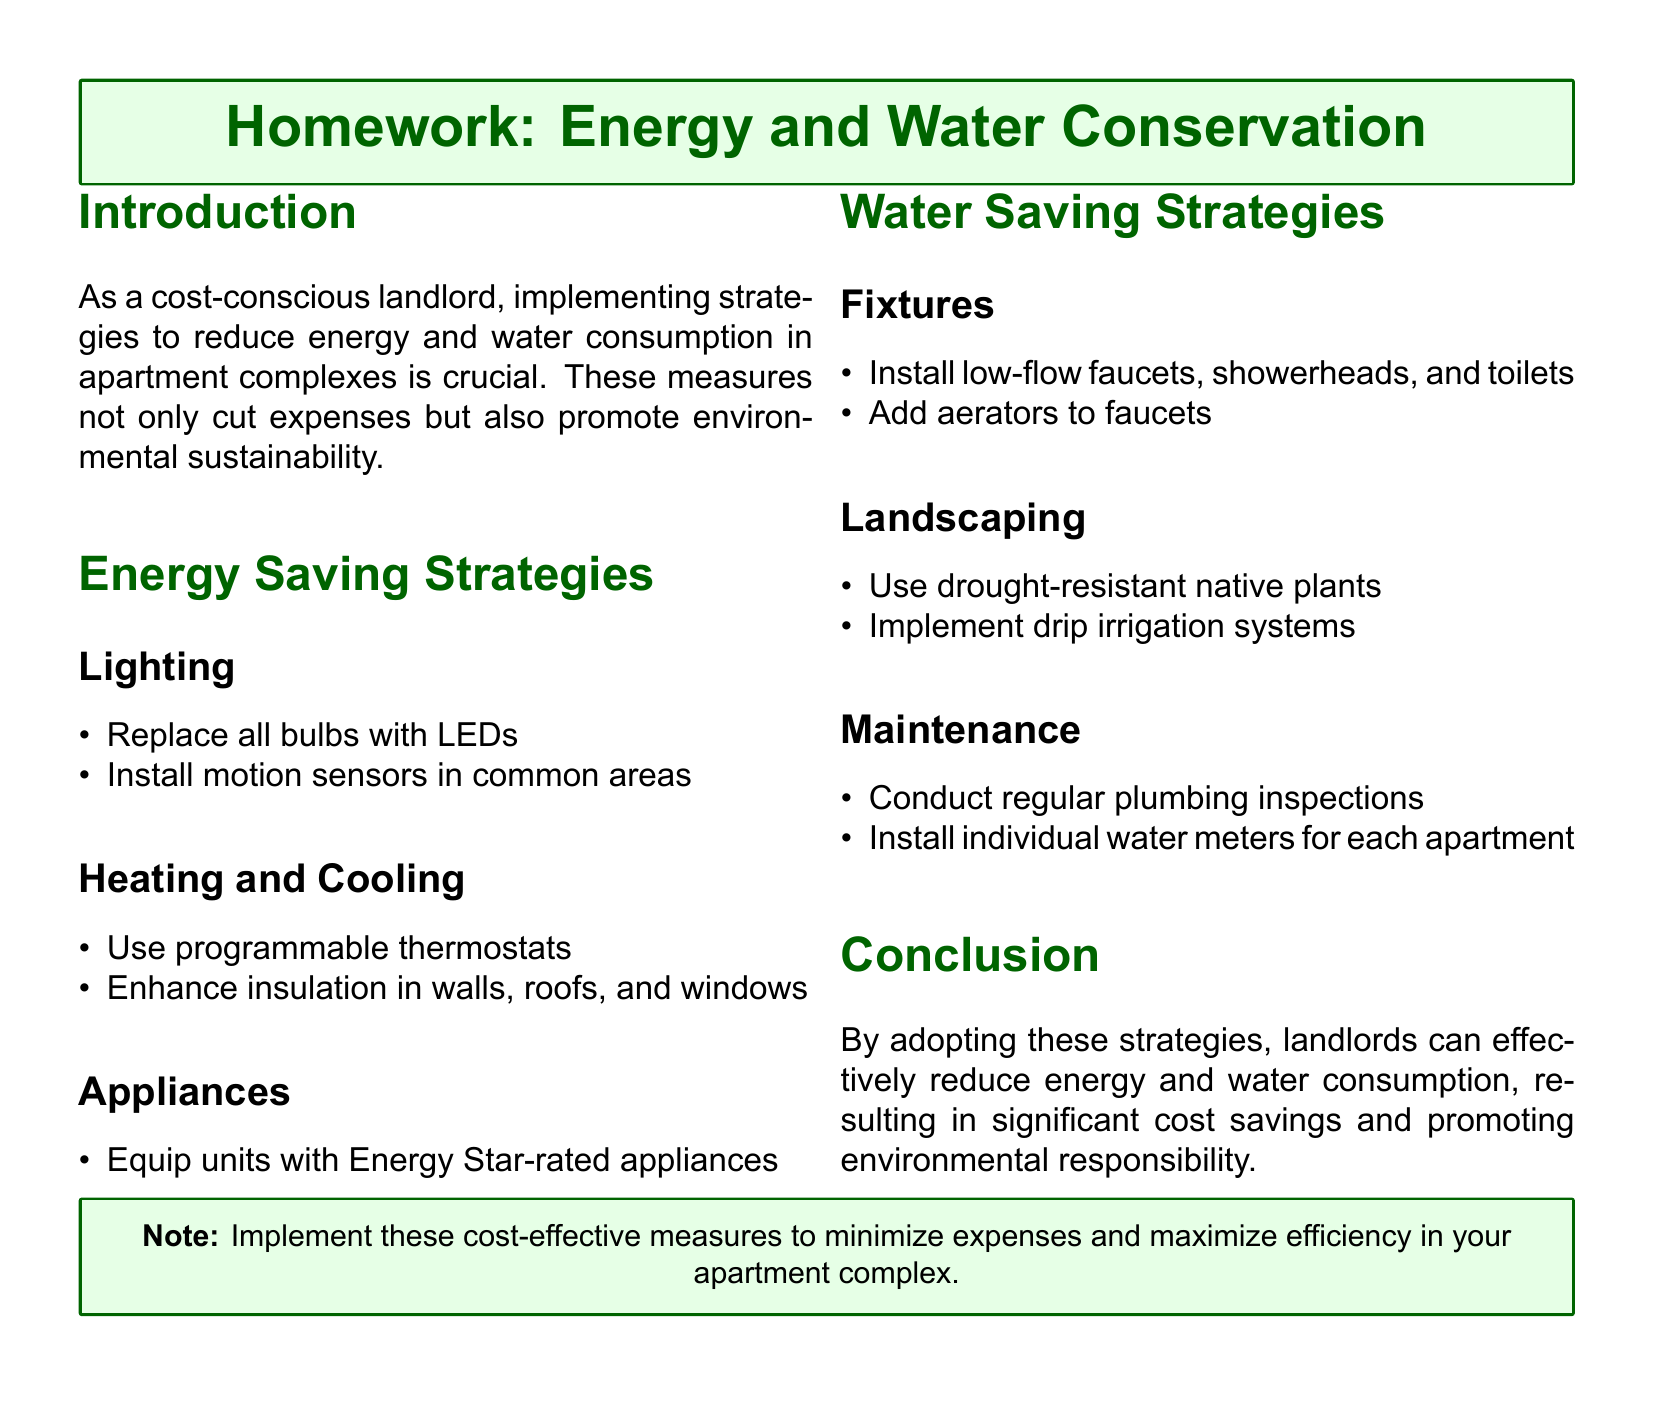what is the main focus of the homework? The main focus is on strategies to reduce energy and water consumption in apartment complexes.
Answer: strategies to reduce energy and water consumption name one energy-saving strategy related to lighting. The document lists strategies for energy savings, specifically under lighting. One example is replacing bulbs.
Answer: Replace all bulbs with LEDs what type of appliances should be used according to the document? The document specifies that Energy Star-rated appliances should be used in the units for energy savings.
Answer: Energy Star-rated appliances what should be installed in each apartment for better water monitoring? The document suggests installing individual water meters to monitor water usage.
Answer: individual water meters name one water-saving fixture mentioned in the document. The document mentions several water-saving fixtures, including low-flow toilets as one of the examples.
Answer: low-flow toilets what is a landscaping strategy to conserve water? The document provides strategies for landscaping that help conserve water, one of which is using native plants.
Answer: Use drought-resistant native plants how can motion sensors contribute to energy savings? The explanation in the document indicates that motion sensors help save energy in common areas by controlling lighting.
Answer: Install motion sensors in common areas identify a maintenance strategy listed for water conservation. The document lists maintenance strategies, including conducting regular plumbing inspections to prevent leaks and save water.
Answer: conduct regular plumbing inspections 